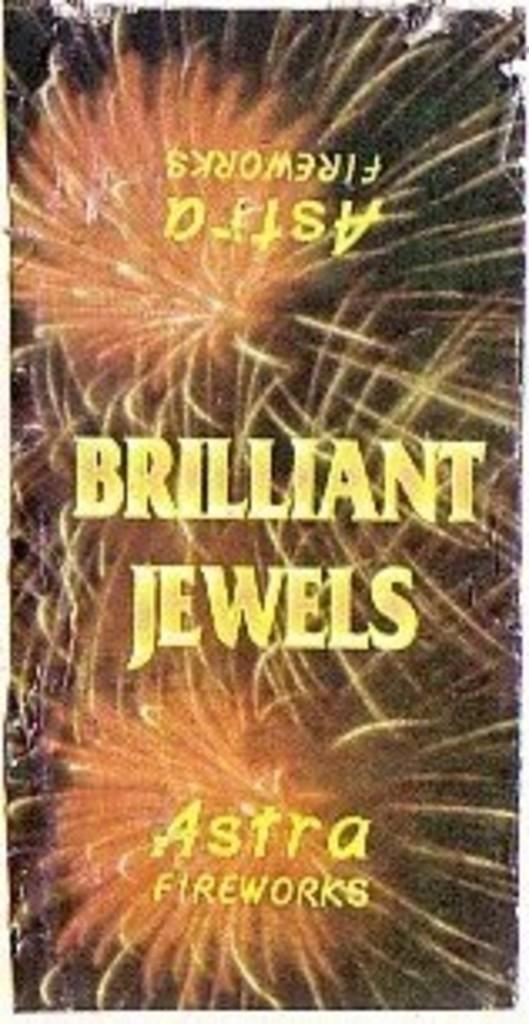Provide a one-sentence caption for the provided image. An ad for Astra fireworks shows bright orange fireworks. 